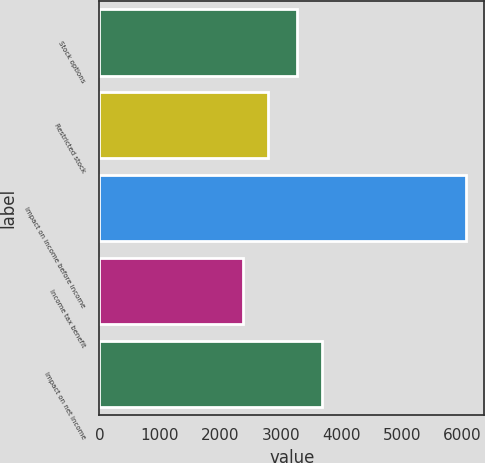Convert chart. <chart><loc_0><loc_0><loc_500><loc_500><bar_chart><fcel>Stock options<fcel>Restricted stock<fcel>Impact on income before income<fcel>Income tax benefit<fcel>Impact on net income<nl><fcel>3273<fcel>2789<fcel>6062<fcel>2382<fcel>3680<nl></chart> 